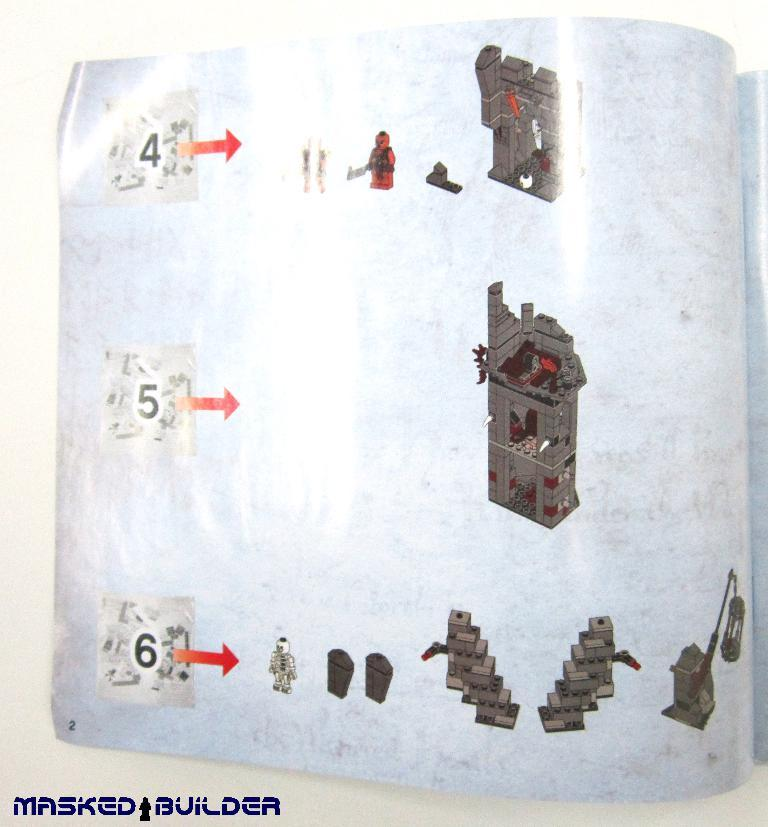What object is present in the image? There is a book in the image. What can be seen on the surface of the book? The book has images, arrow signs, and numbers on its surface. What type of home can be seen in the image? There is no home present in the image; it features a book with images, arrow signs, and numbers on its surface. How does the book affect the heart in the image? There is no mention of a heart or any emotional response in the image; it simply shows a book with various markings on its surface. 